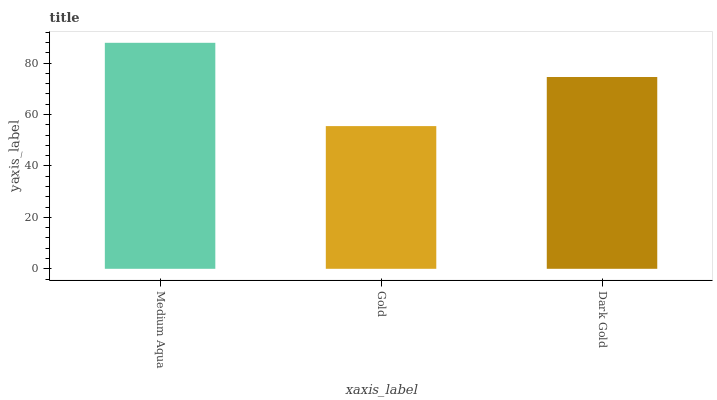Is Dark Gold the minimum?
Answer yes or no. No. Is Dark Gold the maximum?
Answer yes or no. No. Is Dark Gold greater than Gold?
Answer yes or no. Yes. Is Gold less than Dark Gold?
Answer yes or no. Yes. Is Gold greater than Dark Gold?
Answer yes or no. No. Is Dark Gold less than Gold?
Answer yes or no. No. Is Dark Gold the high median?
Answer yes or no. Yes. Is Dark Gold the low median?
Answer yes or no. Yes. Is Medium Aqua the high median?
Answer yes or no. No. Is Medium Aqua the low median?
Answer yes or no. No. 